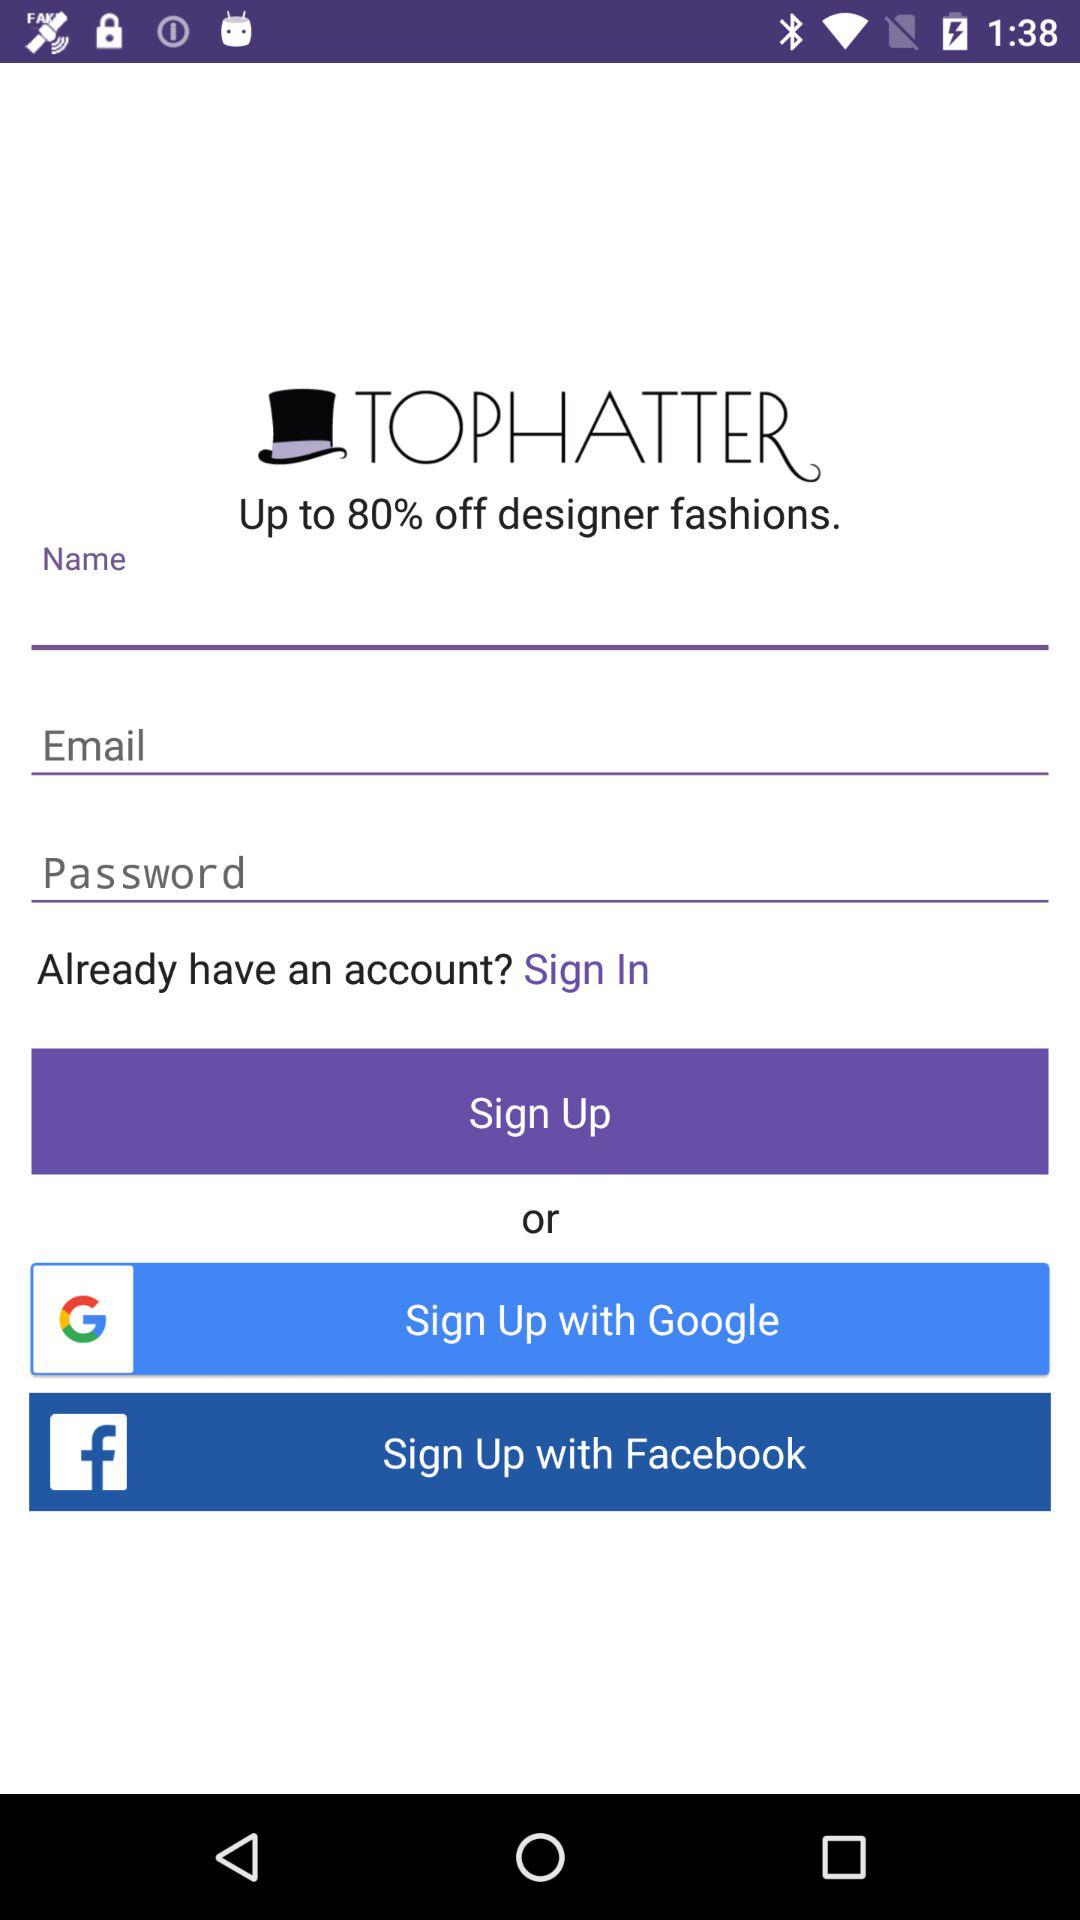Which accounts can I use to sign up? The accounts that can be used to sign up are "Google" and "Facebook". 